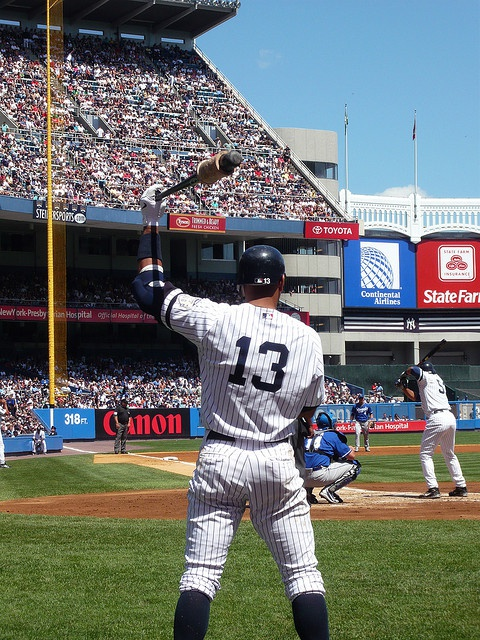Describe the objects in this image and their specific colors. I can see people in black, gray, lightgray, and darkgray tones, people in black, white, gray, and darkgray tones, people in black, white, gray, and darkgray tones, people in black, lightgray, gray, and blue tones, and baseball bat in black, gray, and darkgray tones in this image. 